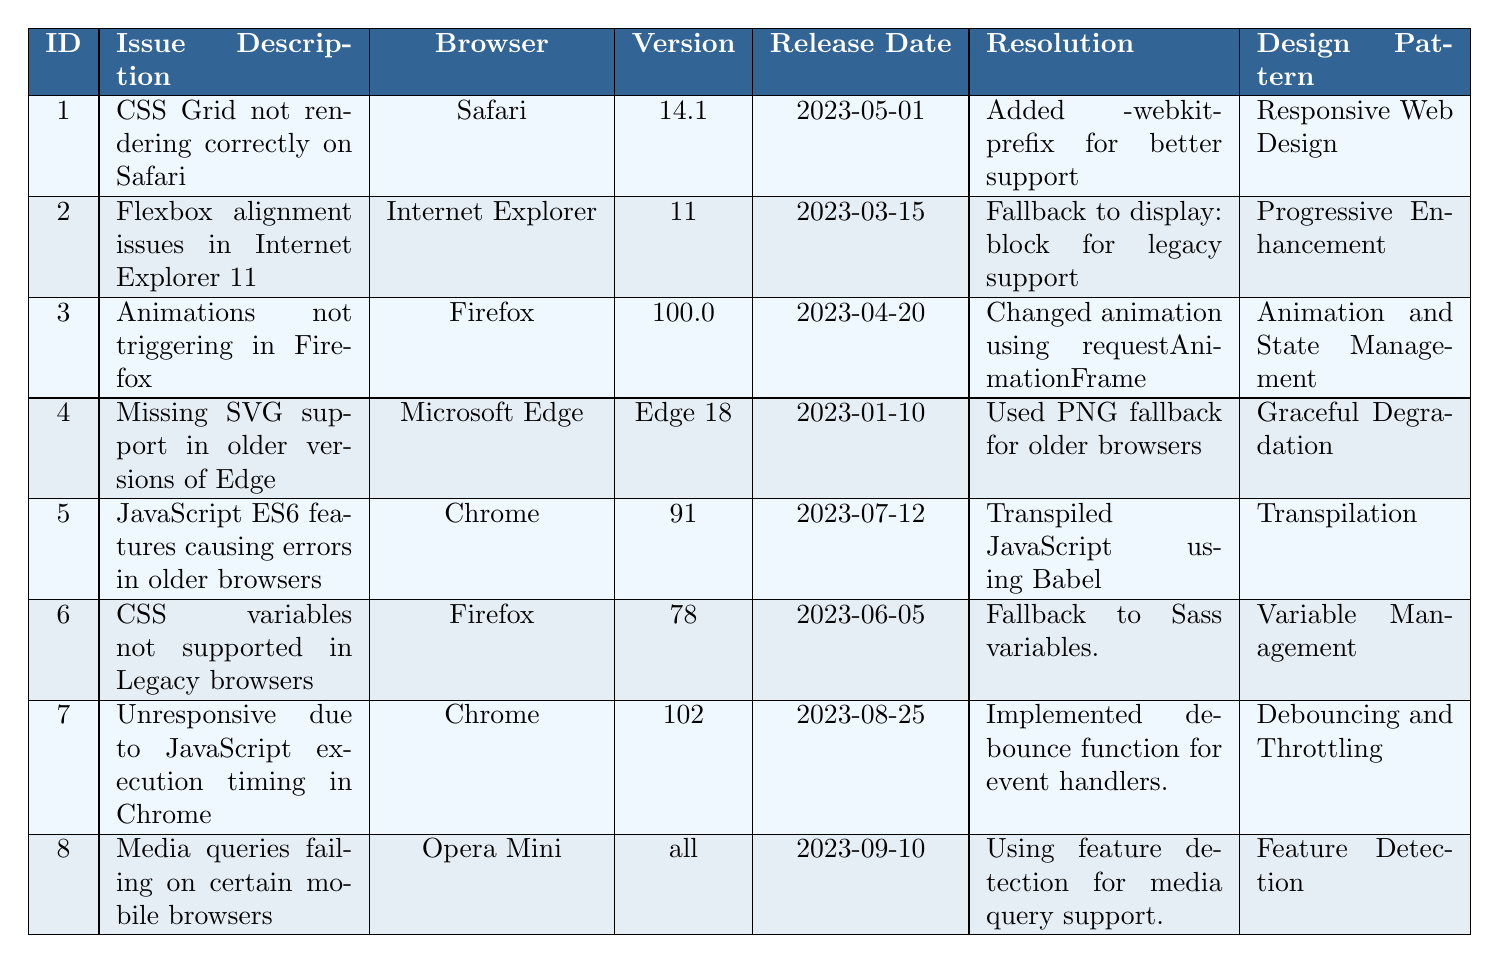What browser had an issue with CSS Grid rendering? The table shows an issue description for CSS Grid rendering on Safari. Reference the row for issue ID 1 to find the browser.
Answer: Safari What was the resolution for the Flexbox alignment issues in Internet Explorer 11? For issue ID 2, the resolution provided states that a fallback to display: block was used for legacy support.
Answer: Fallback to display: block for legacy support How many issues were identified for Chrome? By examining the table, Chrome appears as the affected browser in rows for issue IDs 5 and 7, totaling two issues.
Answer: 2 What design pattern was used to address media queries failing in Opera Mini? Looking at the entry for issue ID 8, the design pattern used is noted as Feature Detection.
Answer: Feature Detection Which browser had the earliest release date for a compatibility issue? Reviewing the release dates, issue ID 4 for Microsoft Edge (release date 2023-01-10) is the earliest when compared to others.
Answer: Microsoft Edge For which issue was the design pattern 'Responsive Web Design' used? The design pattern 'Responsive Web Design' corresponds to issue ID 1, which discusses CSS Grid on Safari.
Answer: CSS Grid on Safari What is the resolution for CSS variables not being supported in Legacy browsers? The resolution provided in issue ID 6 indicates a fallback to Sass variables for compatibility.
Answer: Fallback to Sass variables Which browser had the latest identified issue according to the table? The issue with the latest release date is for Chrome (issue ID 7) on 2023-08-25, making it the most recent entry.
Answer: Chrome What percentage of issues involved Firefox specifically? There are 3 issues related to Firefox (issue IDs 3 and 6). There are 8 total issues in the table, so the percentage is (3/8)*100 = 37.5%.
Answer: 37.5% Is there an issue regarding JavaScript ES6 features causing errors in older browsers? Yes, issue ID 5 discusses JavaScript ES6 features causing errors in older Chrome versions.
Answer: Yes Were there any issues related to Microsoft Edge? Yes, there is one recorded issue (issue ID 4) regarding missing SVG support in older versions of Edge.
Answer: Yes What was the resolution for animations not triggering in Firefox? The resolution from issue ID 3 states that the animation was changed using requestAnimationFrame.
Answer: Changed animation using requestAnimationFrame What is the design pattern used for addressing JavaScript execution timing in Chrome? The design pattern listed for issue ID 7 regarding JavaScript execution timing in Chrome is 'Debouncing and Throttling'.
Answer: Debouncing and Throttling 